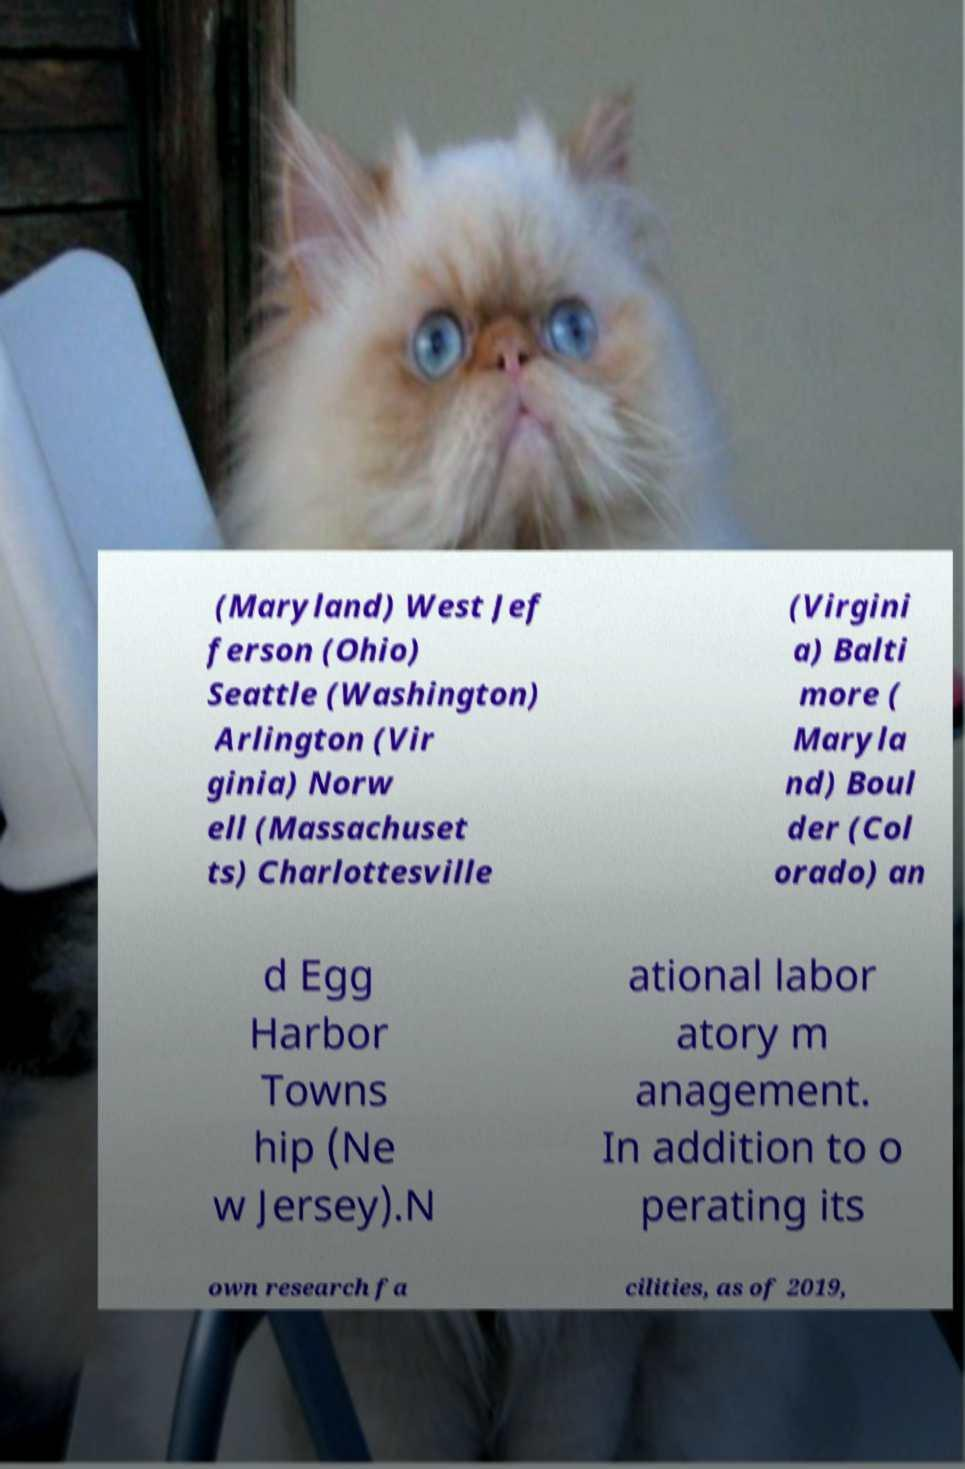Please read and relay the text visible in this image. What does it say? (Maryland) West Jef ferson (Ohio) Seattle (Washington) Arlington (Vir ginia) Norw ell (Massachuset ts) Charlottesville (Virgini a) Balti more ( Maryla nd) Boul der (Col orado) an d Egg Harbor Towns hip (Ne w Jersey).N ational labor atory m anagement. In addition to o perating its own research fa cilities, as of 2019, 